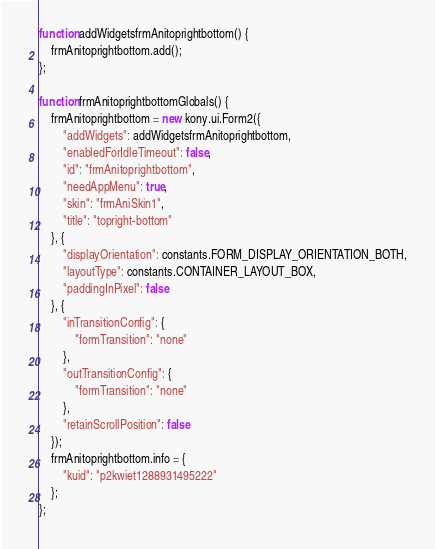Convert code to text. <code><loc_0><loc_0><loc_500><loc_500><_JavaScript_>function addWidgetsfrmAnitoprightbottom() {
    frmAnitoprightbottom.add();
};

function frmAnitoprightbottomGlobals() {
    frmAnitoprightbottom = new kony.ui.Form2({
        "addWidgets": addWidgetsfrmAnitoprightbottom,
        "enabledForIdleTimeout": false,
        "id": "frmAnitoprightbottom",
        "needAppMenu": true,
        "skin": "frmAniSkin1",
        "title": "topright-bottom"
    }, {
        "displayOrientation": constants.FORM_DISPLAY_ORIENTATION_BOTH,
        "layoutType": constants.CONTAINER_LAYOUT_BOX,
        "paddingInPixel": false
    }, {
        "inTransitionConfig": {
            "formTransition": "none"
        },
        "outTransitionConfig": {
            "formTransition": "none"
        },
        "retainScrollPosition": false
    });
    frmAnitoprightbottom.info = {
        "kuid": "p2kwiet1288931495222"
    };
};</code> 